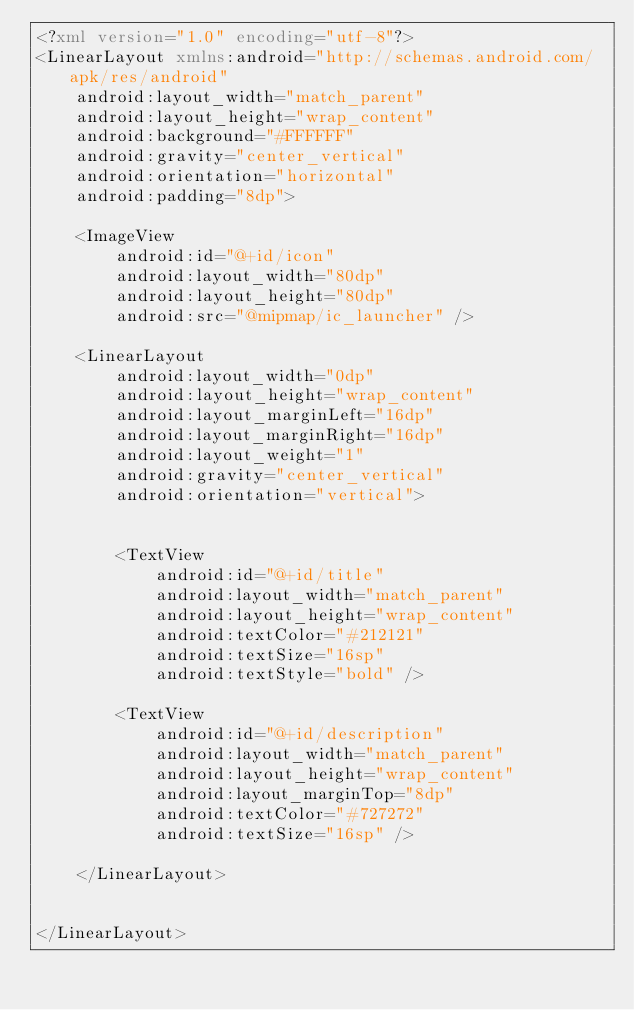<code> <loc_0><loc_0><loc_500><loc_500><_XML_><?xml version="1.0" encoding="utf-8"?>
<LinearLayout xmlns:android="http://schemas.android.com/apk/res/android"
    android:layout_width="match_parent"
    android:layout_height="wrap_content"
    android:background="#FFFFFF"
    android:gravity="center_vertical"
    android:orientation="horizontal"
    android:padding="8dp">

    <ImageView
        android:id="@+id/icon"
        android:layout_width="80dp"
        android:layout_height="80dp"
        android:src="@mipmap/ic_launcher" />

    <LinearLayout
        android:layout_width="0dp"
        android:layout_height="wrap_content"
        android:layout_marginLeft="16dp"
        android:layout_marginRight="16dp"
        android:layout_weight="1"
        android:gravity="center_vertical"
        android:orientation="vertical">


        <TextView
            android:id="@+id/title"
            android:layout_width="match_parent"
            android:layout_height="wrap_content"
            android:textColor="#212121"
            android:textSize="16sp"
            android:textStyle="bold" />

        <TextView
            android:id="@+id/description"
            android:layout_width="match_parent"
            android:layout_height="wrap_content"
            android:layout_marginTop="8dp"
            android:textColor="#727272"
            android:textSize="16sp" />

    </LinearLayout>


</LinearLayout>

</code> 